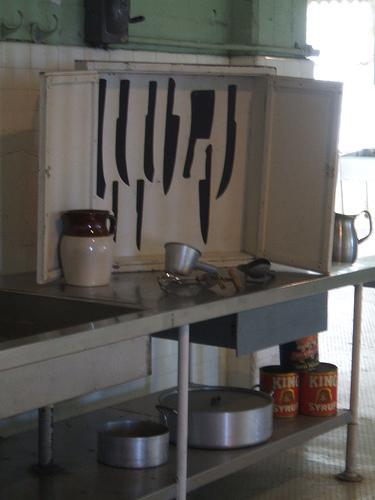Which one of these vegetables is used in the manufacture of the item in the cans?

Choices:
A) eggplant
B) tomato
C) corn
D) pumpkin corn 